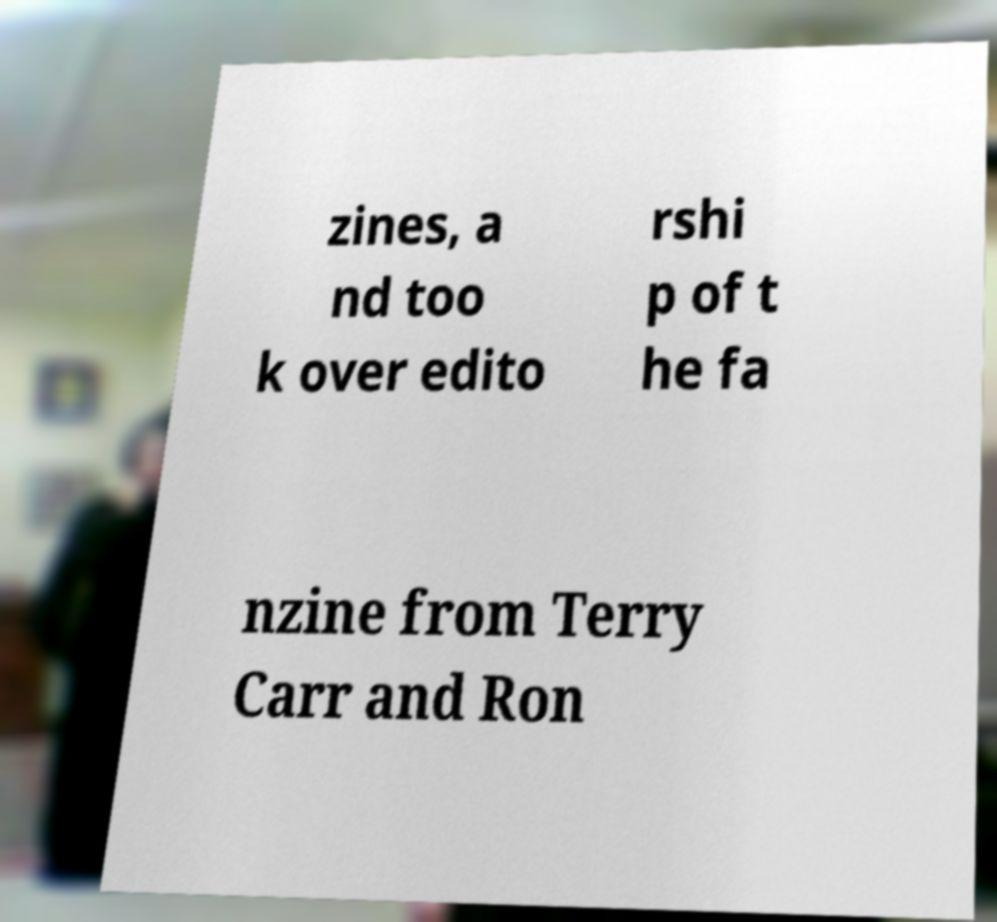Please read and relay the text visible in this image. What does it say? zines, a nd too k over edito rshi p of t he fa nzine from Terry Carr and Ron 